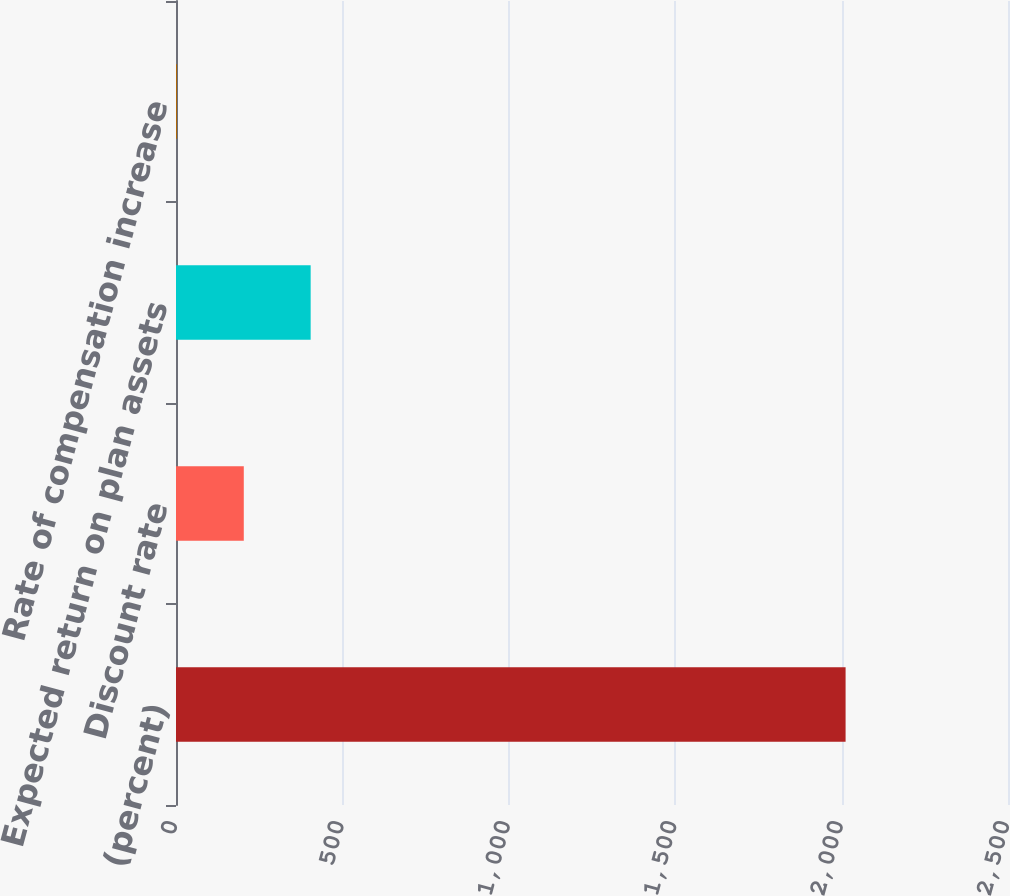Convert chart. <chart><loc_0><loc_0><loc_500><loc_500><bar_chart><fcel>(percent)<fcel>Discount rate<fcel>Expected return on plan assets<fcel>Rate of compensation increase<nl><fcel>2012<fcel>203.7<fcel>404.62<fcel>2.78<nl></chart> 